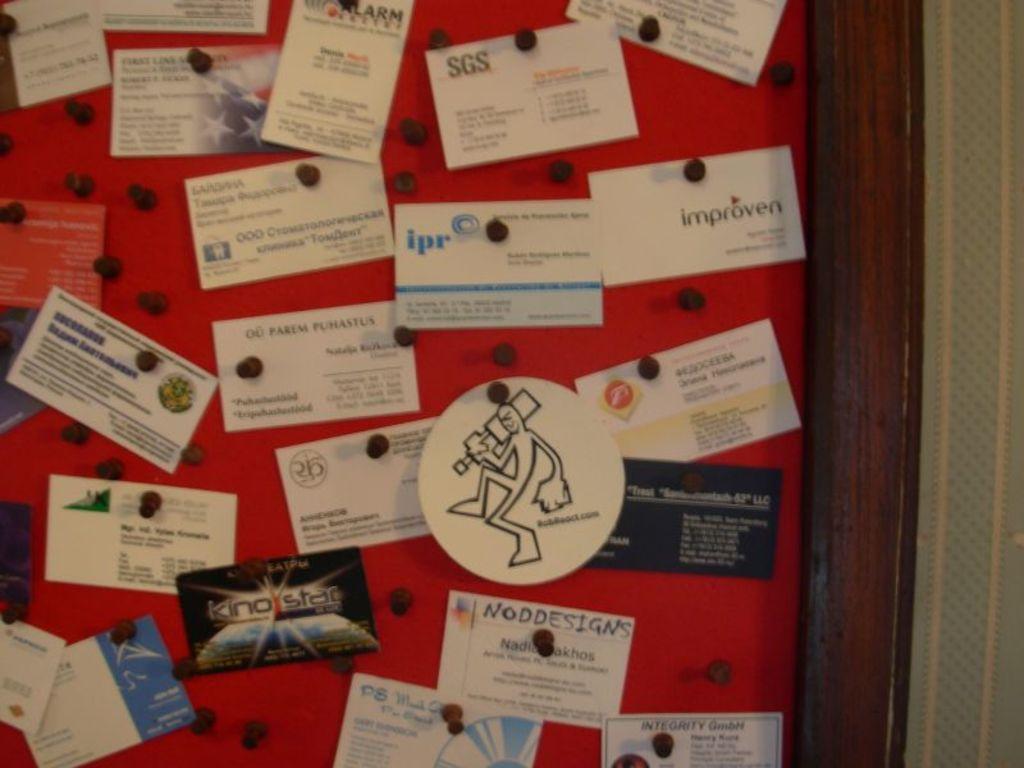Could you give a brief overview of what you see in this image? There are cards which are placed on a board in the image. 